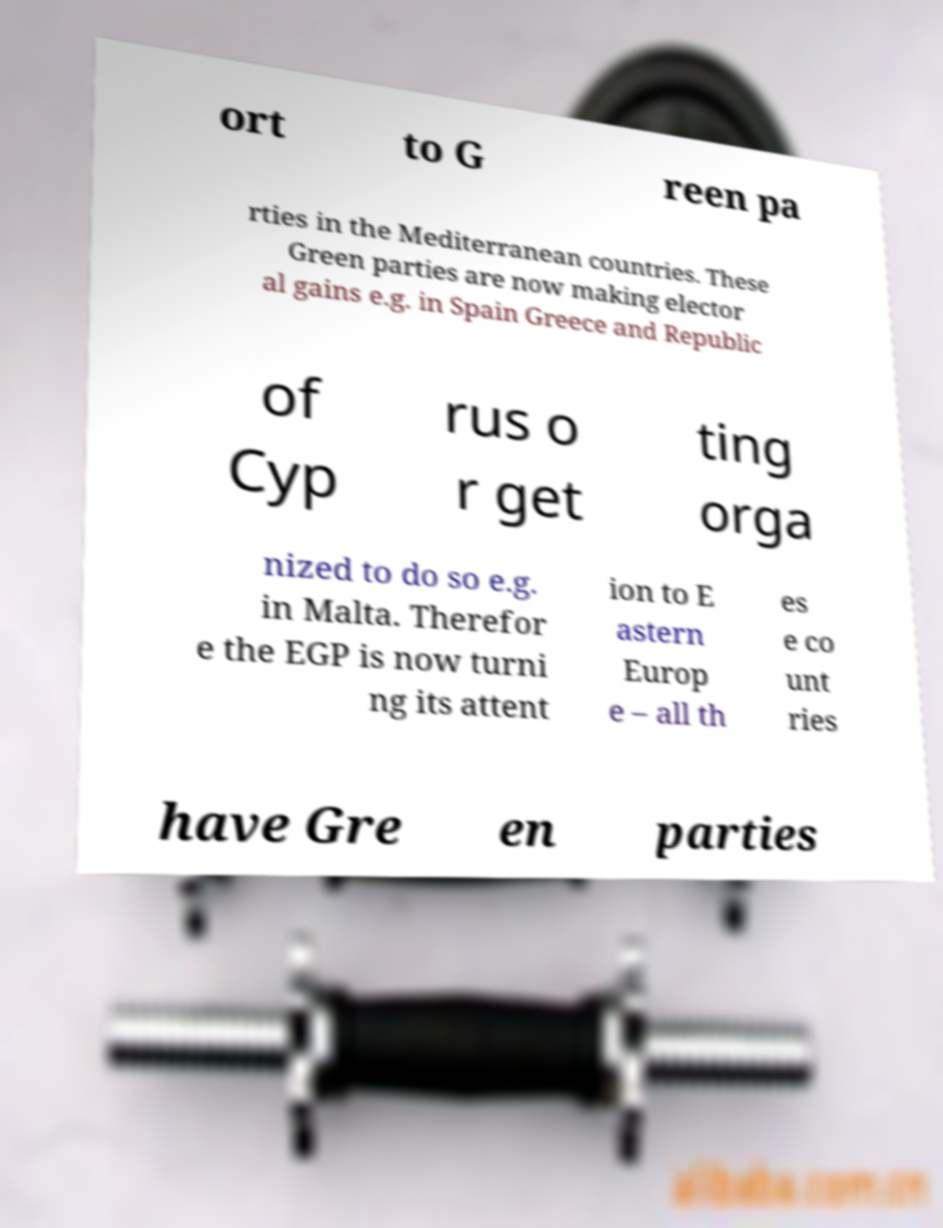For documentation purposes, I need the text within this image transcribed. Could you provide that? ort to G reen pa rties in the Mediterranean countries. These Green parties are now making elector al gains e.g. in Spain Greece and Republic of Cyp rus o r get ting orga nized to do so e.g. in Malta. Therefor e the EGP is now turni ng its attent ion to E astern Europ e – all th es e co unt ries have Gre en parties 